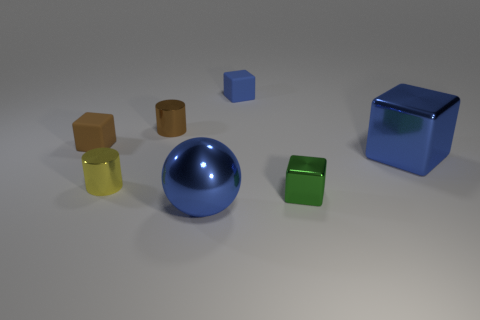Add 1 small brown objects. How many objects exist? 8 Subtract all tiny green cubes. How many cubes are left? 3 Subtract 0 yellow blocks. How many objects are left? 7 Subtract all cubes. How many objects are left? 3 Subtract 2 cubes. How many cubes are left? 2 Subtract all cyan cylinders. Subtract all cyan cubes. How many cylinders are left? 2 Subtract all green cubes. How many yellow cylinders are left? 1 Subtract all cyan matte cylinders. Subtract all yellow metal objects. How many objects are left? 6 Add 5 small brown rubber things. How many small brown rubber things are left? 6 Add 3 yellow things. How many yellow things exist? 4 